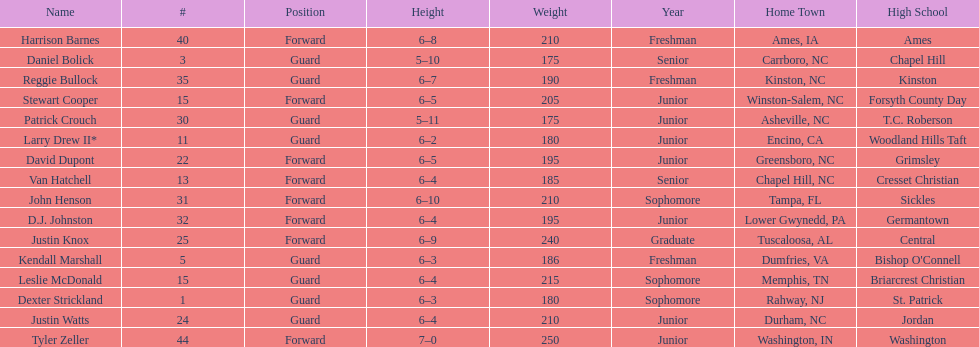How many players are not a junior? 9. 